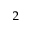Convert formula to latex. <formula><loc_0><loc_0><loc_500><loc_500>_ { 2 }</formula> 